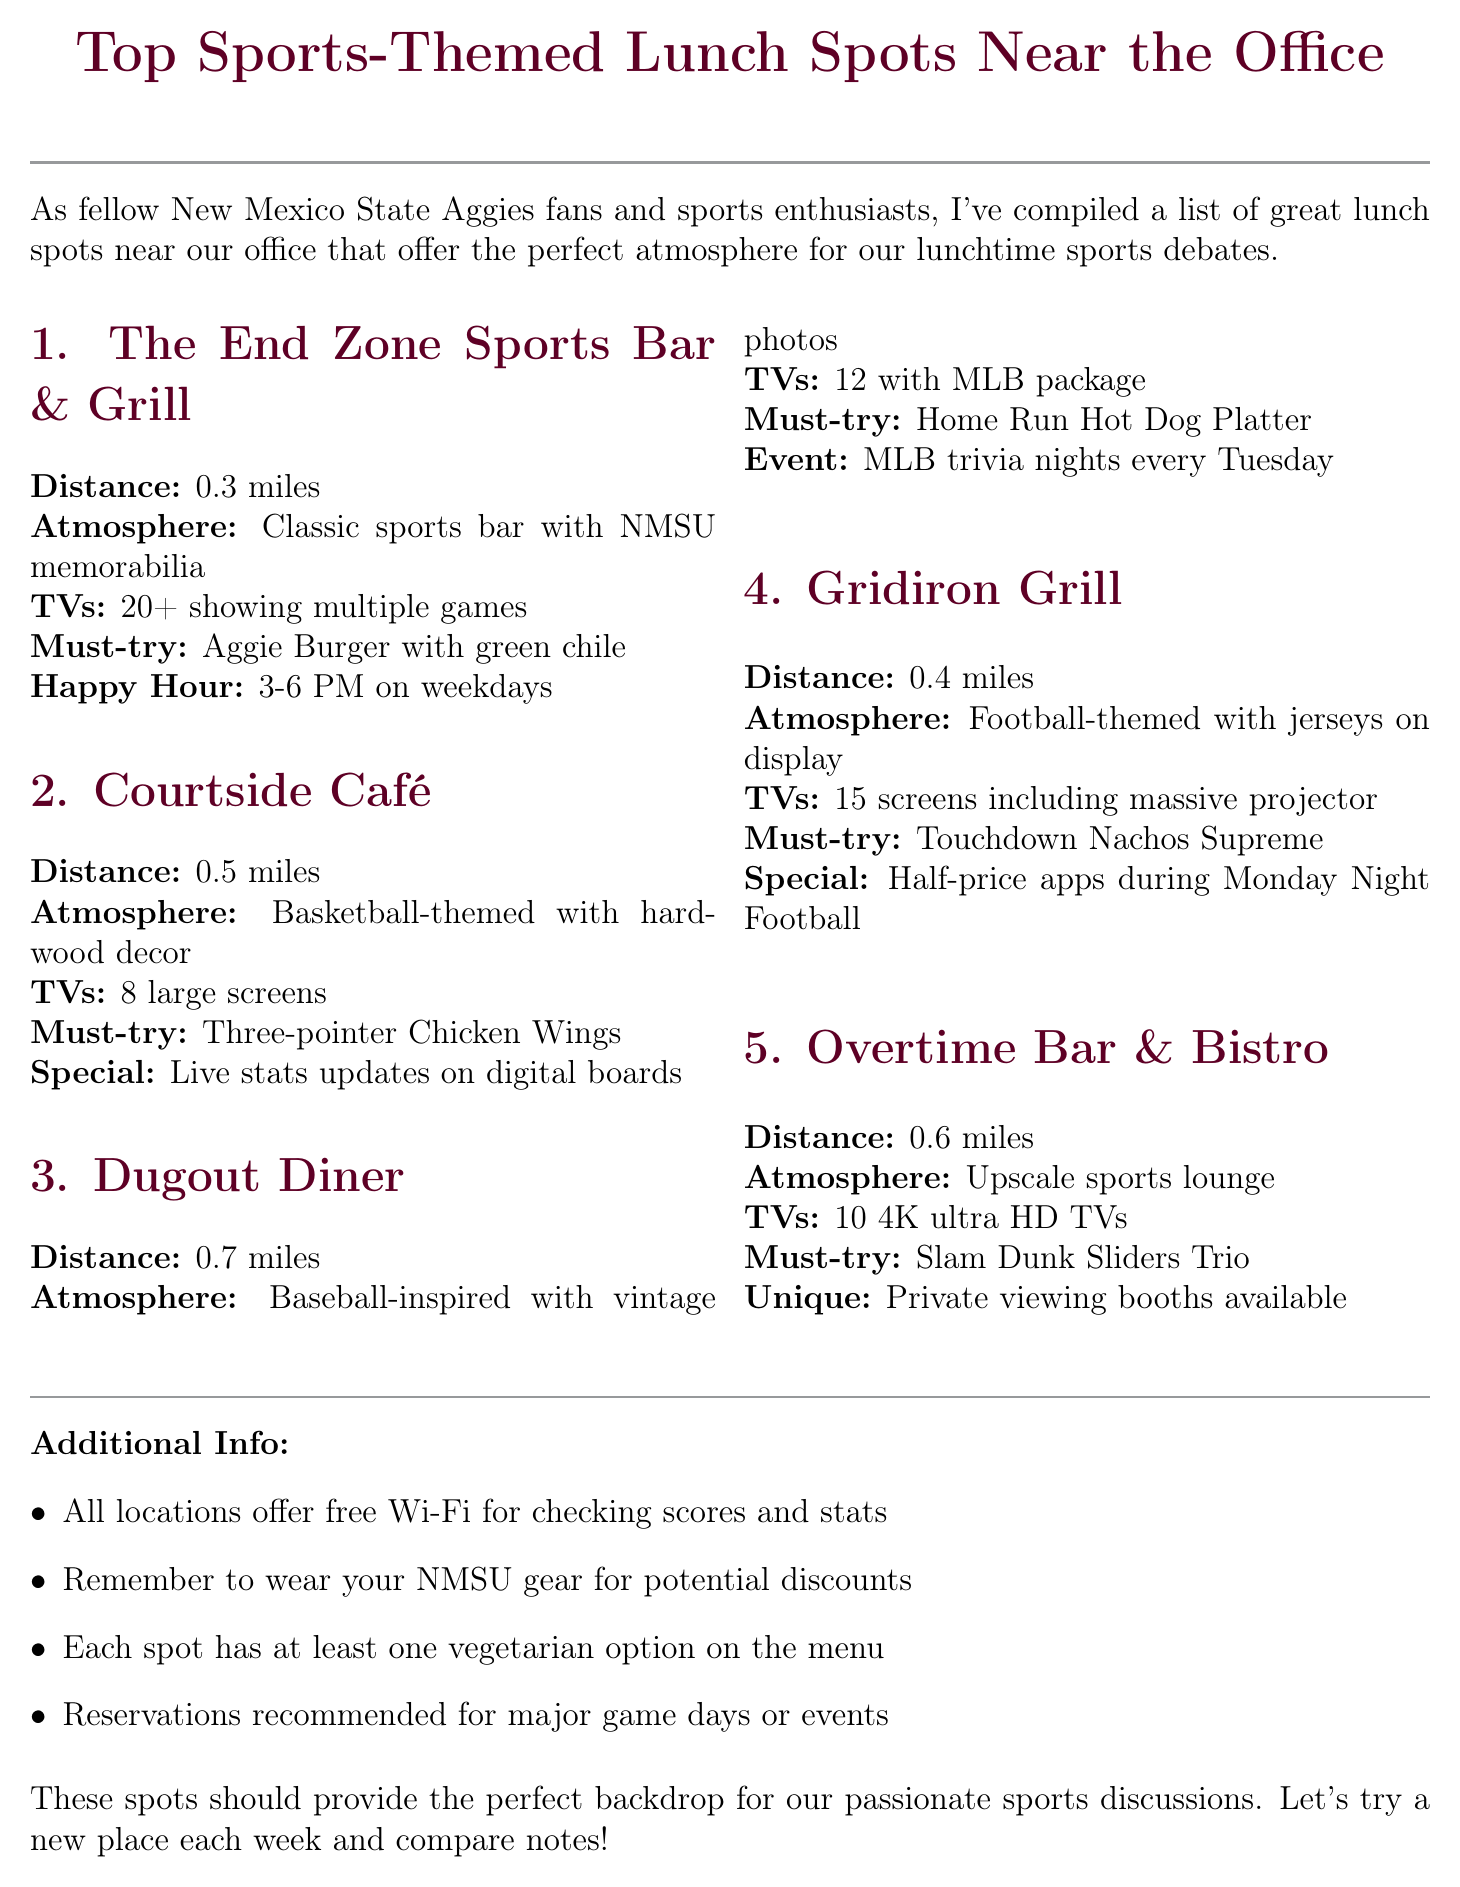What is the distance to The End Zone Sports Bar & Grill? The distance to The End Zone Sports Bar & Grill is mentioned in the lunch spots section of the document.
Answer: 0.3 miles How many TVs does Gridiron Grill have? The number of TVs at Gridiron Grill is specified in the document under the lunch spots section.
Answer: 15 screens What is the signature dish at Courtside Café? The signature dish is listed in the description of Courtside Café within the lunch spots.
Answer: Three-pointer Chicken Wings Which lunch spot has trivia nights? Trivia nights are mentioned specifically under Dugout Diner, making it identifiable.
Answer: Dugout Diner What special feature does Overtime Bar & Bistro offer? The unique feature of Overtime Bar & Bistro is described explicitly in the document.
Answer: Private viewing booths for small groups What is the atmosphere at Dugout Diner? The atmosphere is described in the lunch spots section, allowing identification of the theme.
Answer: Baseball-inspired decor with vintage photos Is happy hour available at Gridiron Grill? The document explicitly states the happy hour times for each restaurant.
Answer: Yes How far is Overtime Bar & Bistro from the office? The distance to Overtime Bar & Bistro is provided in the document, allowing quick retrieval of this information.
Answer: 0.6 miles 